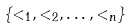<formula> <loc_0><loc_0><loc_500><loc_500>\{ < _ { 1 } , < _ { 2 } , \dots , < _ { n } \}</formula> 